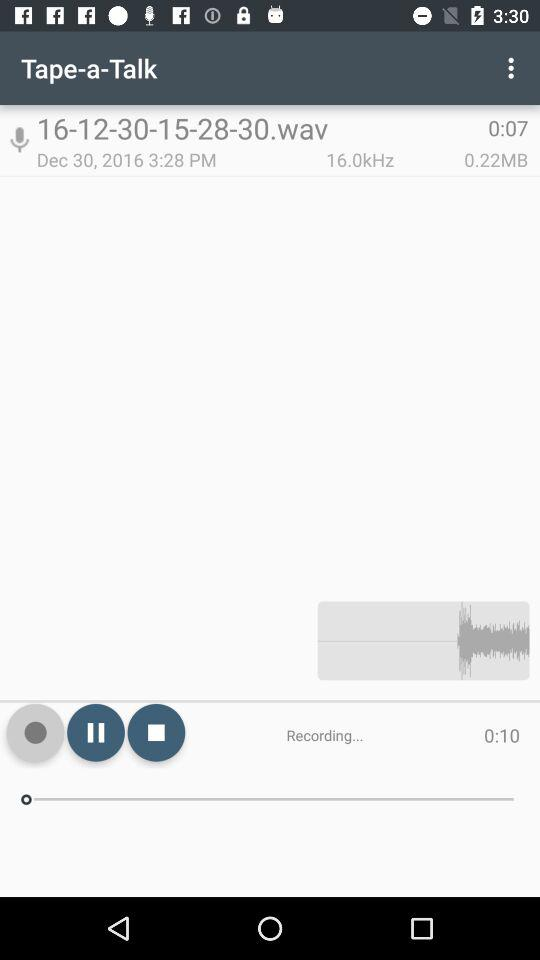What is the date of recording? The date of recording is December 30, 2016. 